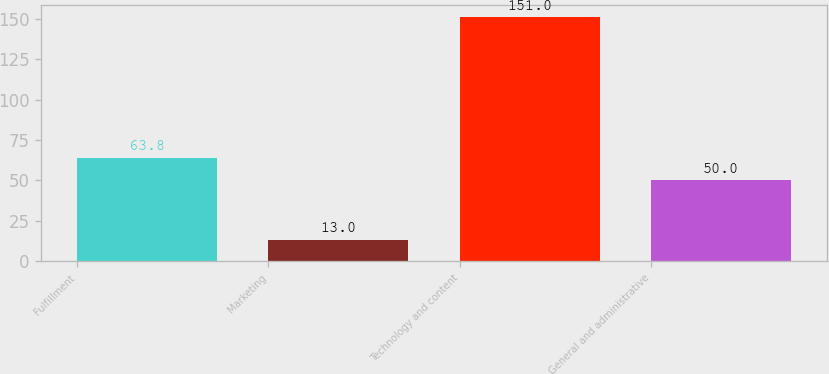Convert chart to OTSL. <chart><loc_0><loc_0><loc_500><loc_500><bar_chart><fcel>Fulfillment<fcel>Marketing<fcel>Technology and content<fcel>General and administrative<nl><fcel>63.8<fcel>13<fcel>151<fcel>50<nl></chart> 